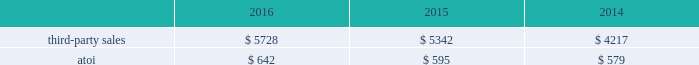December 31 , 2018 .
Alcoa corporation will supply all required raw materials to arconic and arconic will process the raw materials into finished can sheet coils ready for shipment to the end customer .
Tolling revenue for the two months ended december 31 , 2016 was approximately $ 37 million .
In 2017 , demand in the automotive end market is expected to continue to grow due to the growing demand for innovative products and aluminum-intensive vehicles .
Demand from the commercial airframe end market is expected to be flat in 2017 as the ramp up of new programs is offset by customer destocking and lower build rates for aluminum intensive wide-body programs .
Sales to the packaging market are expected to decline due to continuing pricing pressure within this market and the ramp-down of the north american packaging operations .
Net productivity improvements are anticipated to continue .
Engineered products and solutions .
The engineered products and solutions segment produces products that are used primarily in the aerospace ( commercial and defense ) , commercial transportation , and power generation end markets .
Such products include fastening systems ( titanium , steel , and nickel superalloys ) and seamless rolled rings ( mostly nickel superalloys ) ; investment castings ( nickel superalloys , titanium , and aluminum ) , including airfoils and forged jet engine components ( e.g. , jet engine disks ) , and extruded , machined and formed aircraft parts ( titanium and aluminum ) , all of which are sold directly to customers and through distributors .
More than 75% ( 75 % ) of the third-party sales in this segment are from the aerospace end market .
A small part of this segment also produces various forged , extruded , and machined metal products ( titanium , aluminum and steel ) for the oil and gas , industrial products , automotive , and land and sea defense end markets .
Seasonal decreases in sales are generally experienced in the third quarter of the year due to the european summer slowdown across all end markets .
Generally , the sales and costs and expenses of this segment are transacted in the local currency of the respective operations , which are mostly the u.s .
Dollar , british pound and the euro .
In july 2015 , arconic completed the acquisition of rti , a global supplier of titanium and specialty metal products and services for the commercial aerospace , defense , energy , and medical device end markets .
The purpose of the acquisition was to expand arconic 2019s range of titanium offerings and add advanced technologies and materials , primarily related to the aerospace end market .
In 2014 , rti generated net sales of $ 794 and had approximately 2600 employees .
The operating results and assets and liabilities of rti have been included within the engineered products and solutions segment since the date of acquisition .
In march 2015 , arconic completed the acquisition of tital , a privately held aerospace castings company with approximately 650 employees based in germany .
Tital produces aluminum and titanium investment casting products for the aerospace and defense end markets .
In 2014 , tital generated sales of approximately $ 100 .
The purpose of the acquisition was to capture increasing demand for advanced jet engine components made of titanium , establish titanium- casting capabilities in europe , and expand existing aluminum casting capacity .
The operating results and assets and liabilities of tital have been included within the engineered products and solutions segment since the date of acquisition .
In november 2014 , arconic completed the acquisition of firth rixson , a global leader in aerospace jet engine components .
Firth rixson manufactures rings , forgings , and metal products for the aerospace end market , as well as other markets requiring highly-engineered material applications .
The purpose of the acquisition was to strengthen arconic 2019s aerospace business and position the company to capture additional aerospace growth with a broader range of high-growth , value-add jet engine components .
Firth rixson generated sales of approximately $ 970 in 2014 and had 13 operating facilities in the united states , united kingdom , europe , and asia employing approximately 2400 people combined .
The operating results and assets and liabilities of firth rixson have been included within the engineered products and solutions segment since the date of acquisition. .
Considering the year 2014 , how bigger were the number of dollars received from sales generated from firth rixson in comparison with tital? 
Rationale: it is the percentual increase of the number of dollars received from firth rixson concerning tital.\\n
Computations: (((970 / 100) * 100) - 100)
Answer: 870.0. 